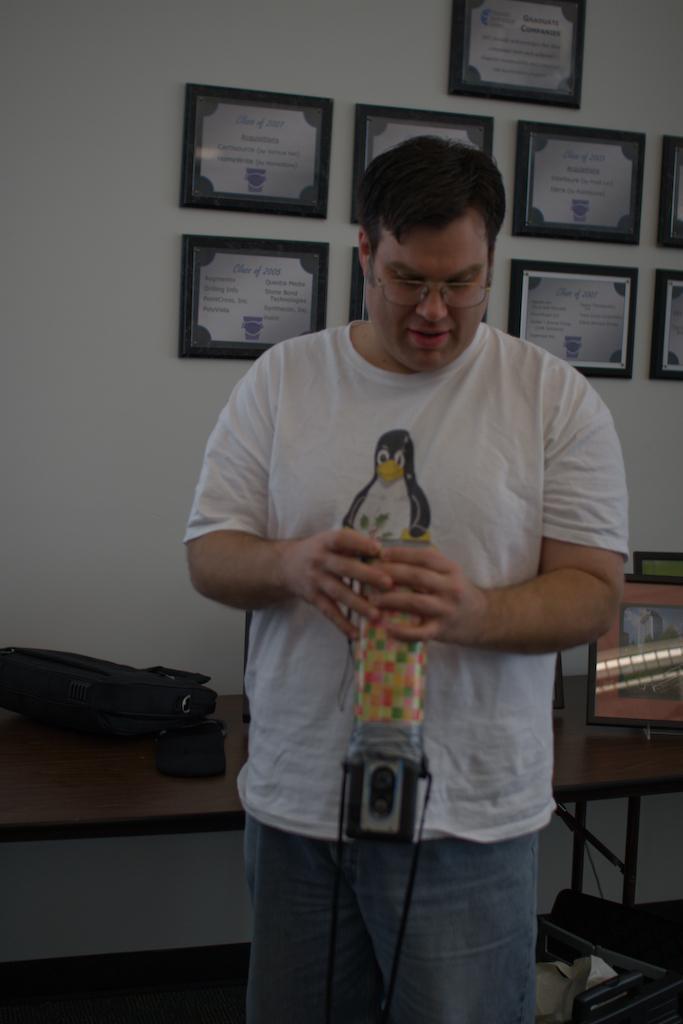Describe this image in one or two sentences. In this picture there is a man who is wearing t-shirt and jeans. He is holding a glass. Behind him I can see the camera and other objects on the table. In the back I can see the frames which are placed on the wall. 